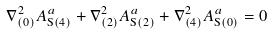<formula> <loc_0><loc_0><loc_500><loc_500>\nabla ^ { 2 } _ { ( 0 ) } A _ { \text {S} ( 4 ) } ^ { a } + \nabla ^ { 2 } _ { ( 2 ) } A _ { \text {S} ( 2 ) } ^ { a } + \nabla ^ { 2 } _ { ( 4 ) } A _ { \text {S} ( 0 ) } ^ { a } = 0</formula> 